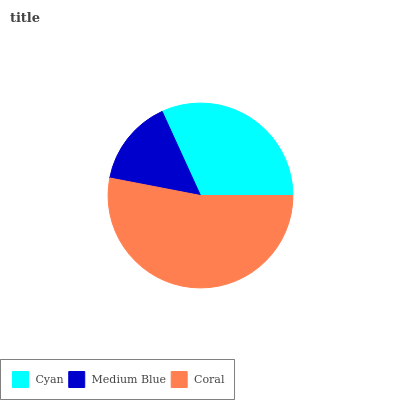Is Medium Blue the minimum?
Answer yes or no. Yes. Is Coral the maximum?
Answer yes or no. Yes. Is Coral the minimum?
Answer yes or no. No. Is Medium Blue the maximum?
Answer yes or no. No. Is Coral greater than Medium Blue?
Answer yes or no. Yes. Is Medium Blue less than Coral?
Answer yes or no. Yes. Is Medium Blue greater than Coral?
Answer yes or no. No. Is Coral less than Medium Blue?
Answer yes or no. No. Is Cyan the high median?
Answer yes or no. Yes. Is Cyan the low median?
Answer yes or no. Yes. Is Medium Blue the high median?
Answer yes or no. No. Is Coral the low median?
Answer yes or no. No. 